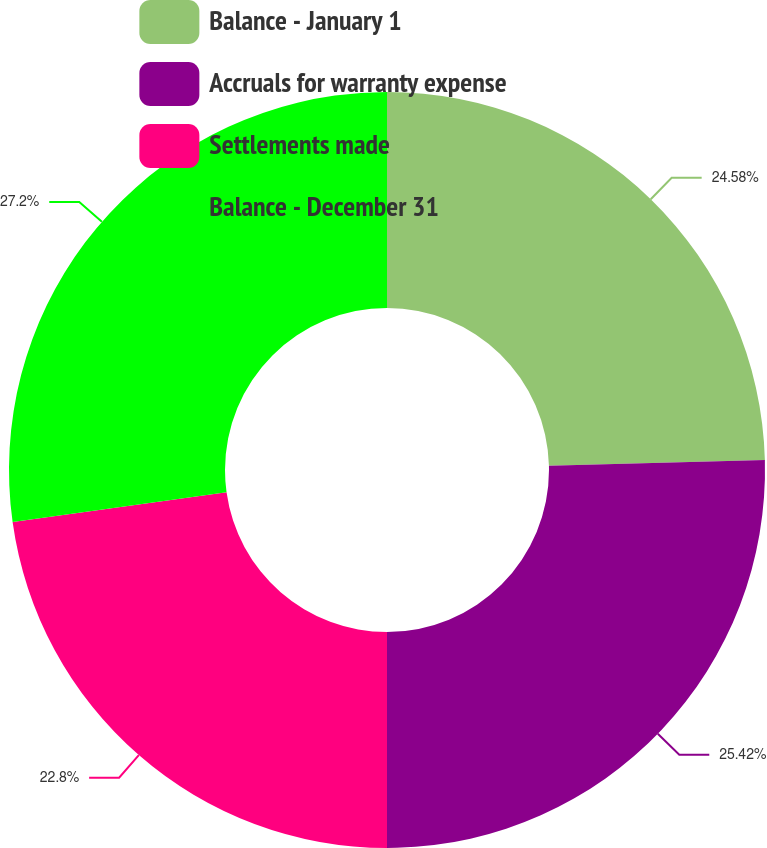Convert chart. <chart><loc_0><loc_0><loc_500><loc_500><pie_chart><fcel>Balance - January 1<fcel>Accruals for warranty expense<fcel>Settlements made<fcel>Balance - December 31<nl><fcel>24.58%<fcel>25.42%<fcel>22.8%<fcel>27.2%<nl></chart> 